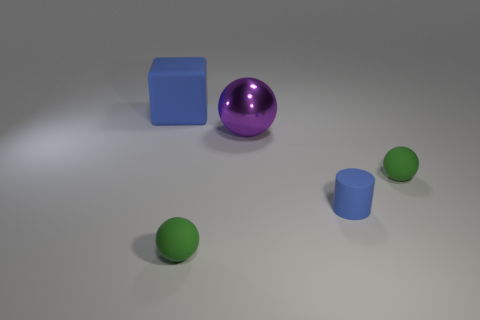Comparing the sizes, which is the second largest object? The second largest object in this tranquil composition is the blue cube. It stands with a solid and sturdy form, positioned between the commanding purple sphere, the centerpiece of this image, and the duo of vibrant green spheres. 